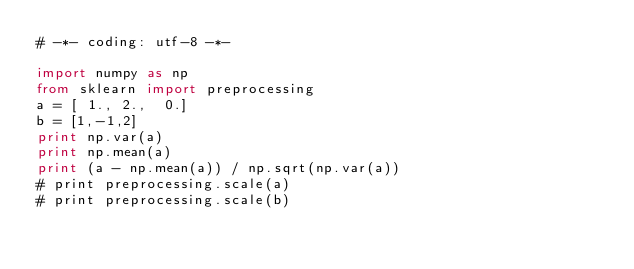<code> <loc_0><loc_0><loc_500><loc_500><_Python_># -*- coding: utf-8 -*-

import numpy as np
from sklearn import preprocessing
a = [ 1., 2.,  0.]
b = [1,-1,2]
print np.var(a)
print np.mean(a)
print (a - np.mean(a)) / np.sqrt(np.var(a))
# print preprocessing.scale(a)
# print preprocessing.scale(b)</code> 